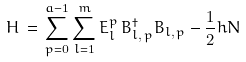Convert formula to latex. <formula><loc_0><loc_0><loc_500><loc_500>H \, = \, \sum _ { p = 0 } ^ { a - 1 } \sum _ { l = 1 } ^ { m } E ^ { p } _ { l } \, B ^ { \dagger } _ { l , \, p } B _ { l , \, p } - \frac { 1 } { 2 } h N</formula> 